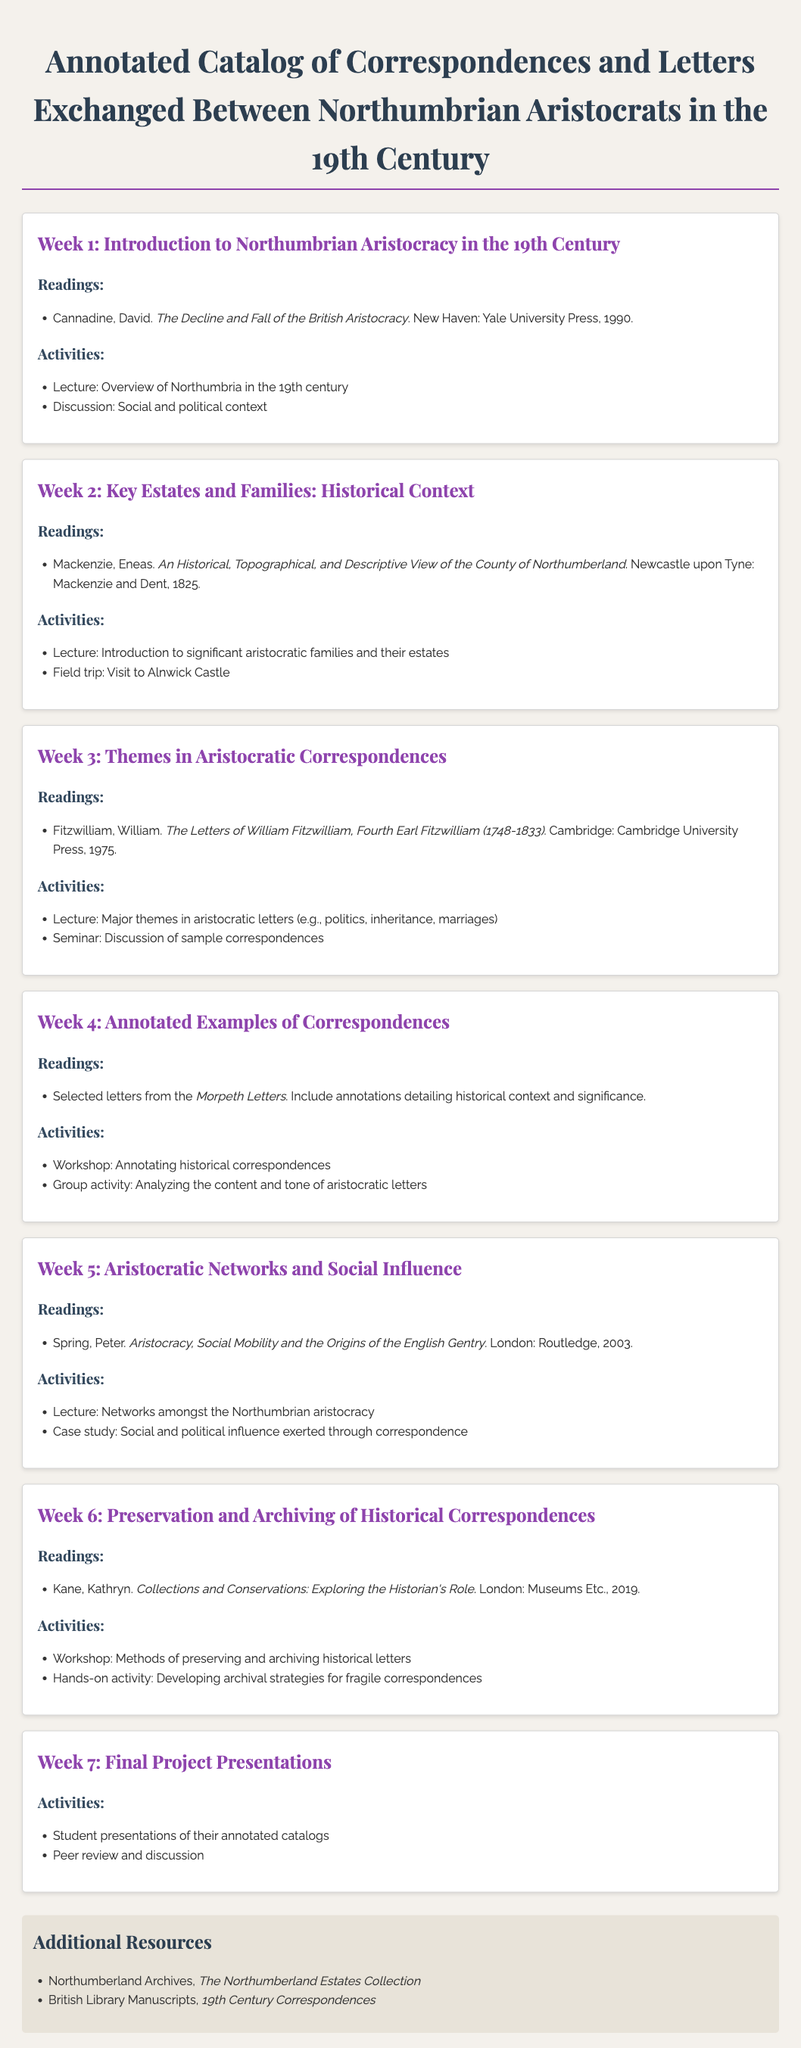What is the title of the syllabus? The title of the syllabus is prominently displayed at the top of the document.
Answer: Annotated Catalog of Correspondences and Letters Exchanged Between Northumbrian Aristocrats in the 19th Century Who wrote "The Decline and Fall of the British Aristocracy"? This information is found in the readings listed in Week 1's section.
Answer: David Cannadine In which year was "An Historical, Topographical, and Descriptive View of the County of Northumberland" published? This detail is provided in the readings listed in Week 2's section.
Answer: 1825 What type of activity is included in Week 4? The structure of each week's activities specifies various types of engagements for students.
Answer: Workshop Which castle is mentioned for the field trip in Week 2? This information is outlined in the activities section of Week 2.
Answer: Alnwick Castle What is the focus of Week 5's lecture? The document states the topic of lectures within the activities section for Week 5.
Answer: Networks amongst the Northumbrian aristocracy What is the main theme of Week 3's activities? The activities listed in Week 3 provide insights into the thematic discussions planned.
Answer: Major themes in aristocratic letters How many weeks are covered in this syllabus? The total number of weekly sections in the syllabus indicates the length of the course.
Answer: 7 